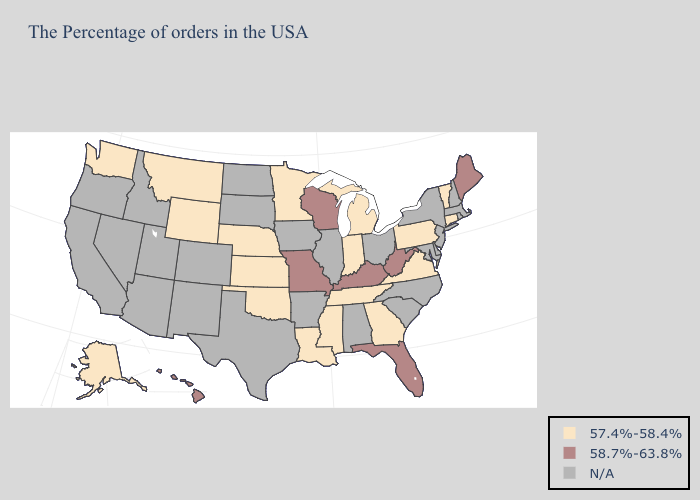What is the value of Nevada?
Quick response, please. N/A. Is the legend a continuous bar?
Concise answer only. No. Name the states that have a value in the range 58.7%-63.8%?
Answer briefly. Maine, West Virginia, Florida, Kentucky, Wisconsin, Missouri, Hawaii. Does the map have missing data?
Write a very short answer. Yes. What is the highest value in the South ?
Answer briefly. 58.7%-63.8%. Does Hawaii have the lowest value in the West?
Quick response, please. No. Name the states that have a value in the range 58.7%-63.8%?
Be succinct. Maine, West Virginia, Florida, Kentucky, Wisconsin, Missouri, Hawaii. What is the value of Pennsylvania?
Answer briefly. 57.4%-58.4%. What is the value of New Hampshire?
Answer briefly. N/A. Among the states that border Massachusetts , which have the highest value?
Give a very brief answer. Vermont, Connecticut. What is the value of New York?
Concise answer only. N/A. Among the states that border Colorado , which have the highest value?
Write a very short answer. Kansas, Nebraska, Oklahoma, Wyoming. What is the value of Ohio?
Quick response, please. N/A. Does Wisconsin have the highest value in the USA?
Short answer required. Yes. What is the value of Illinois?
Answer briefly. N/A. 